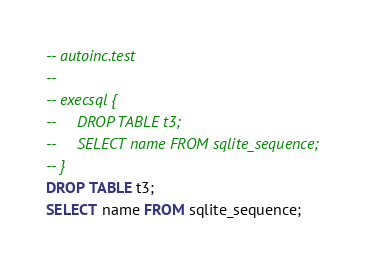<code> <loc_0><loc_0><loc_500><loc_500><_SQL_>-- autoinc.test
-- 
-- execsql {
--     DROP TABLE t3;
--     SELECT name FROM sqlite_sequence;
-- }
DROP TABLE t3;
SELECT name FROM sqlite_sequence;</code> 